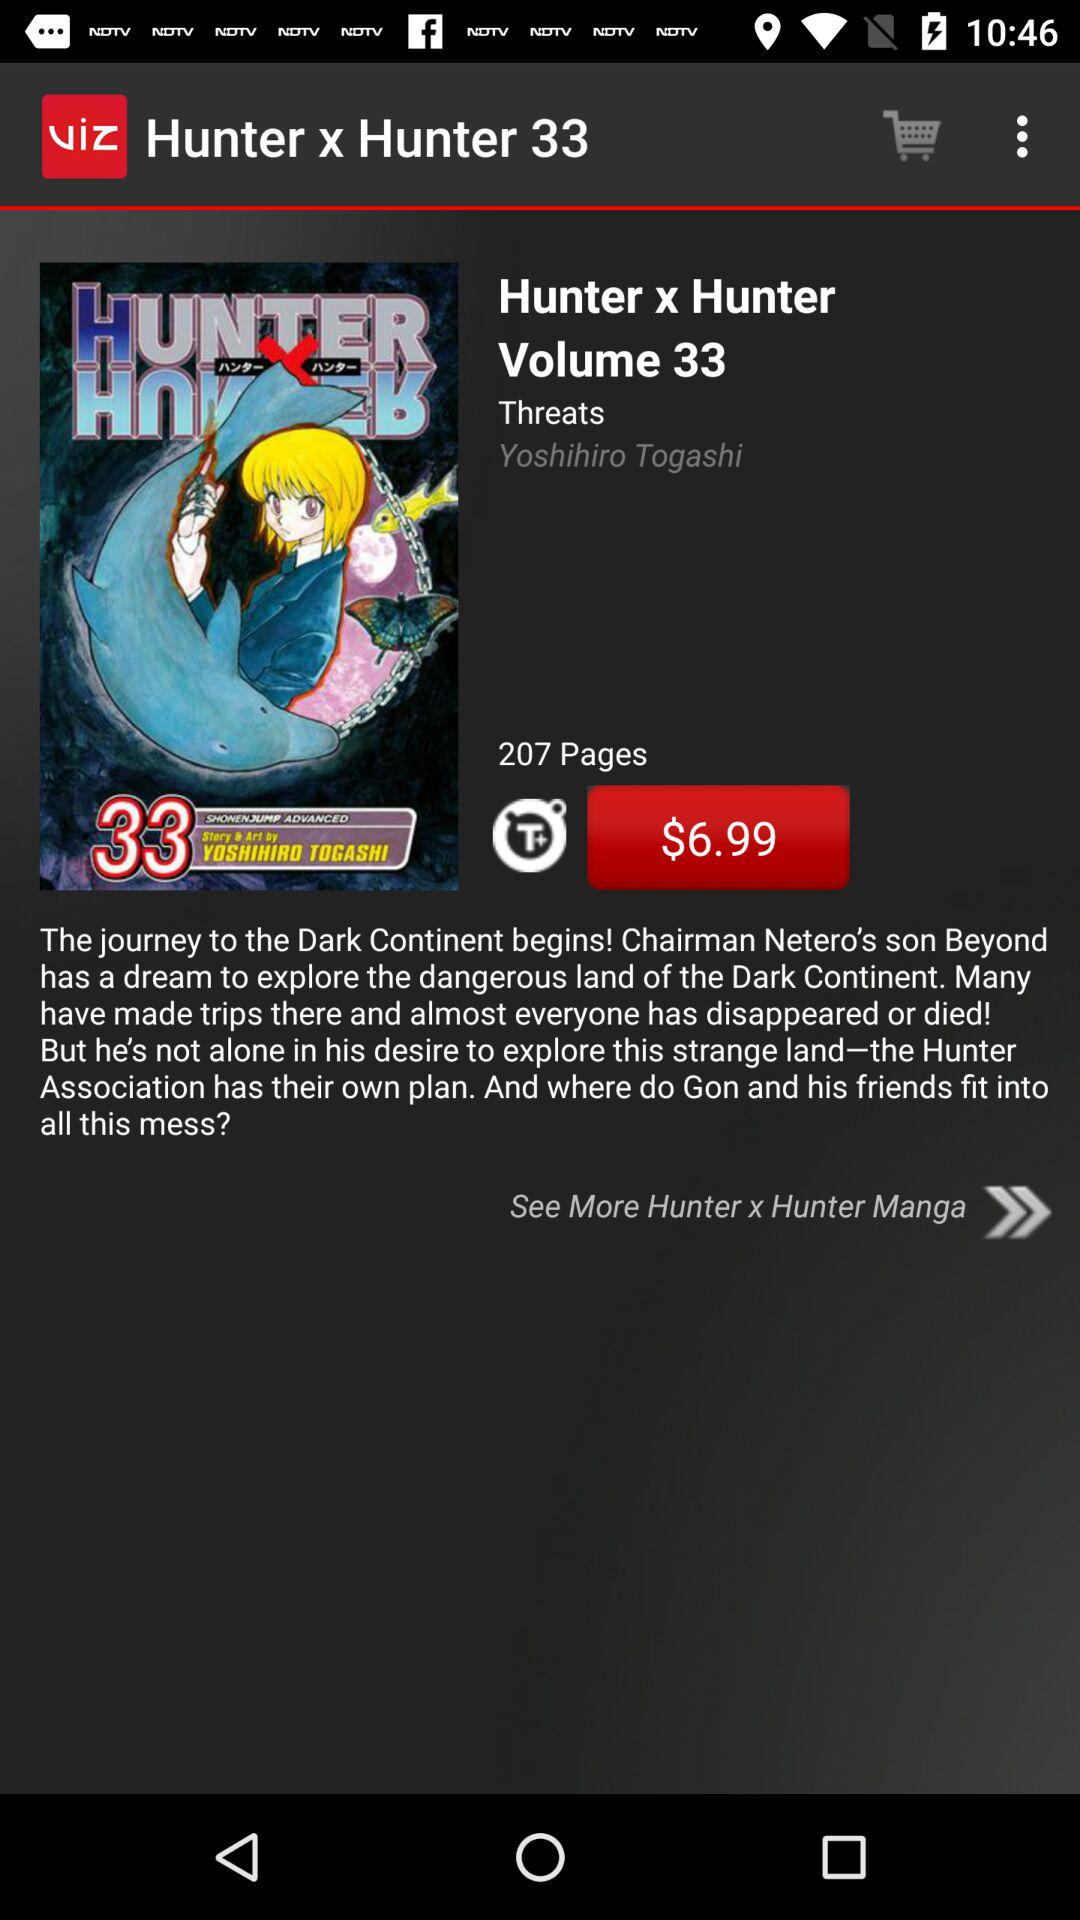How many pages does the book have?
Answer the question using a single word or phrase. 207 